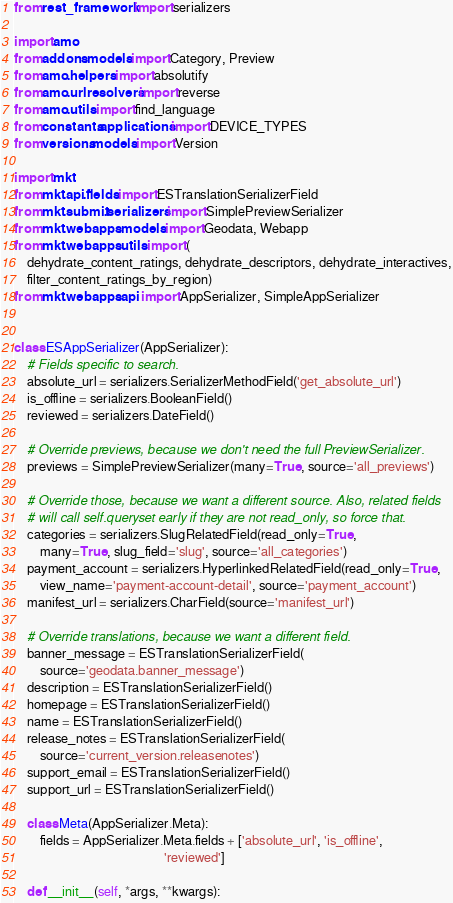Convert code to text. <code><loc_0><loc_0><loc_500><loc_500><_Python_>from rest_framework import serializers

import amo
from addons.models import Category, Preview
from amo.helpers import absolutify
from amo.urlresolvers import reverse
from amo.utils import find_language
from constants.applications import DEVICE_TYPES
from versions.models import Version

import mkt
from mkt.api.fields import ESTranslationSerializerField
from mkt.submit.serializers import SimplePreviewSerializer
from mkt.webapps.models import Geodata, Webapp
from mkt.webapps.utils import (
    dehydrate_content_ratings, dehydrate_descriptors, dehydrate_interactives,
    filter_content_ratings_by_region)
from mkt.webapps.api import AppSerializer, SimpleAppSerializer


class ESAppSerializer(AppSerializer):
    # Fields specific to search.
    absolute_url = serializers.SerializerMethodField('get_absolute_url')
    is_offline = serializers.BooleanField()
    reviewed = serializers.DateField()

    # Override previews, because we don't need the full PreviewSerializer.
    previews = SimplePreviewSerializer(many=True, source='all_previews')

    # Override those, because we want a different source. Also, related fields
    # will call self.queryset early if they are not read_only, so force that.
    categories = serializers.SlugRelatedField(read_only=True,
        many=True, slug_field='slug', source='all_categories')
    payment_account = serializers.HyperlinkedRelatedField(read_only=True,
        view_name='payment-account-detail', source='payment_account')
    manifest_url = serializers.CharField(source='manifest_url')

    # Override translations, because we want a different field.
    banner_message = ESTranslationSerializerField(
        source='geodata.banner_message')
    description = ESTranslationSerializerField()
    homepage = ESTranslationSerializerField()
    name = ESTranslationSerializerField()
    release_notes = ESTranslationSerializerField(
        source='current_version.releasenotes')
    support_email = ESTranslationSerializerField()
    support_url = ESTranslationSerializerField()

    class Meta(AppSerializer.Meta):
        fields = AppSerializer.Meta.fields + ['absolute_url', 'is_offline',
                                              'reviewed']

    def __init__(self, *args, **kwargs):</code> 